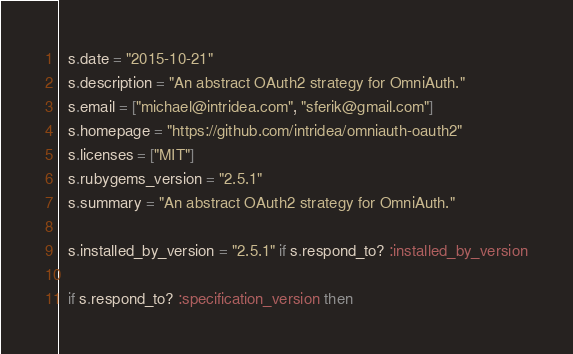Convert code to text. <code><loc_0><loc_0><loc_500><loc_500><_Ruby_>  s.date = "2015-10-21"
  s.description = "An abstract OAuth2 strategy for OmniAuth."
  s.email = ["michael@intridea.com", "sferik@gmail.com"]
  s.homepage = "https://github.com/intridea/omniauth-oauth2"
  s.licenses = ["MIT"]
  s.rubygems_version = "2.5.1"
  s.summary = "An abstract OAuth2 strategy for OmniAuth."

  s.installed_by_version = "2.5.1" if s.respond_to? :installed_by_version

  if s.respond_to? :specification_version then</code> 